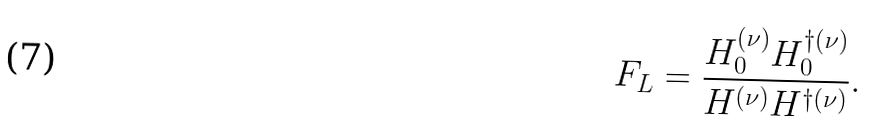<formula> <loc_0><loc_0><loc_500><loc_500>F _ { L } = \frac { H ^ { ( \nu ) } _ { 0 } H ^ { \dag ( \nu ) } _ { 0 } } { H ^ { ( \nu ) } H ^ { \dag ( \nu ) } } .</formula> 